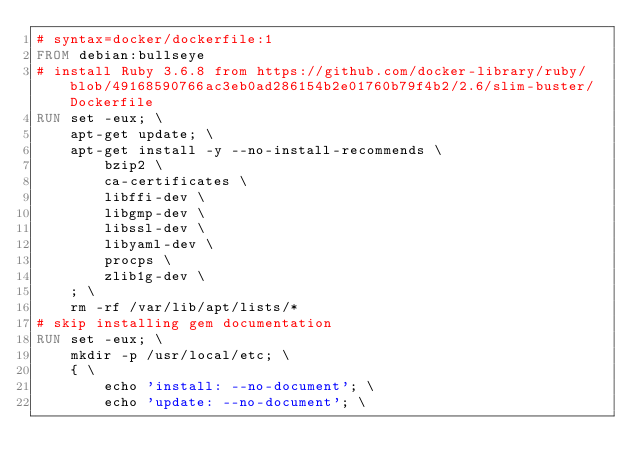<code> <loc_0><loc_0><loc_500><loc_500><_Dockerfile_># syntax=docker/dockerfile:1
FROM debian:bullseye
# install Ruby 3.6.8 from https://github.com/docker-library/ruby/blob/49168590766ac3eb0ad286154b2e01760b79f4b2/2.6/slim-buster/Dockerfile
RUN set -eux; \
	apt-get update; \
	apt-get install -y --no-install-recommends \
		bzip2 \
		ca-certificates \
		libffi-dev \
		libgmp-dev \
		libssl-dev \
		libyaml-dev \
		procps \
		zlib1g-dev \
	; \
	rm -rf /var/lib/apt/lists/*
# skip installing gem documentation
RUN set -eux; \
	mkdir -p /usr/local/etc; \
	{ \
		echo 'install: --no-document'; \
		echo 'update: --no-document'; \</code> 